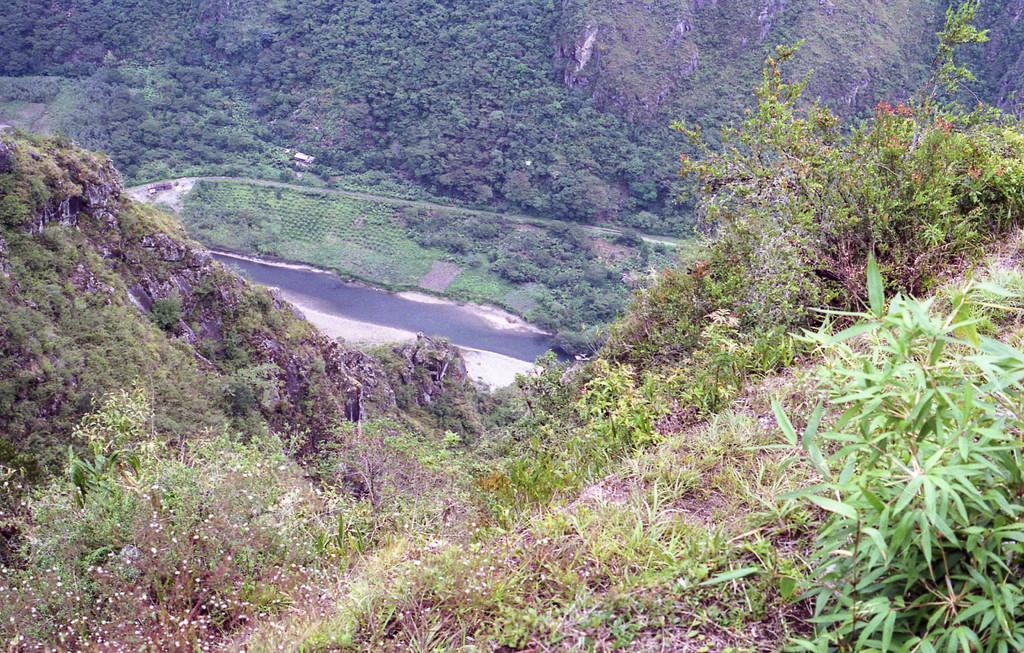Please provide a concise description of this image. On the left side, there are trees and plants on a mountain. On the right side, there are trees, plants and grass on a mountain. In the background, there are trees, plants and mountains. 